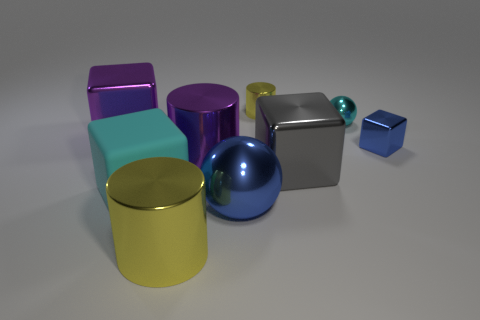Subtract all tiny blocks. How many blocks are left? 3 Subtract all purple blocks. How many blocks are left? 3 Subtract all blue blocks. How many yellow cylinders are left? 2 Subtract 2 cubes. How many cubes are left? 2 Add 1 large metallic balls. How many objects exist? 10 Subtract all blocks. How many objects are left? 5 Subtract all brown cylinders. Subtract all brown cubes. How many cylinders are left? 3 Subtract all matte objects. Subtract all cyan rubber things. How many objects are left? 7 Add 7 large purple cylinders. How many large purple cylinders are left? 8 Add 3 gray metallic cubes. How many gray metallic cubes exist? 4 